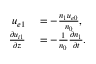<formula> <loc_0><loc_0><loc_500><loc_500>\begin{array} { r l } { u _ { e 1 } } & = - \frac { n _ { 1 } u _ { e 0 } } { n _ { 0 } } , } \\ { \frac { \partial u _ { i 1 } } { \partial z } } & = - \frac { 1 } { n _ { 0 } } \frac { \partial n _ { 1 } } { \partial t } . } \end{array}</formula> 